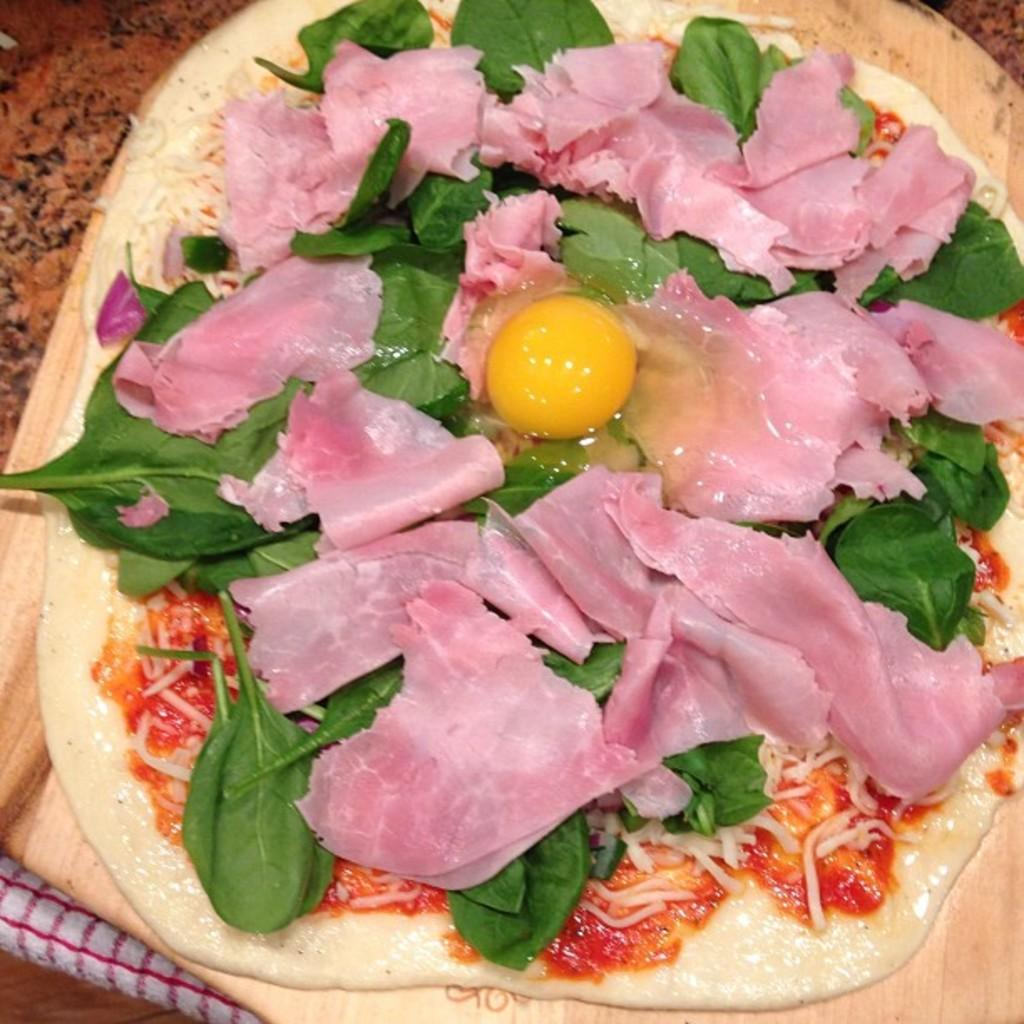What type of furniture is present in the image? There is a table in the image. What is covering the table? There is a white and red color cloth on the table. What is placed on top of the cloth? There is a pan on the table. What is inside the pan? There is a food item in the pan. What type of suit is hanging on the wall in the image? There is no suit present in the image; it only features a table, cloth, pan, and food item. 